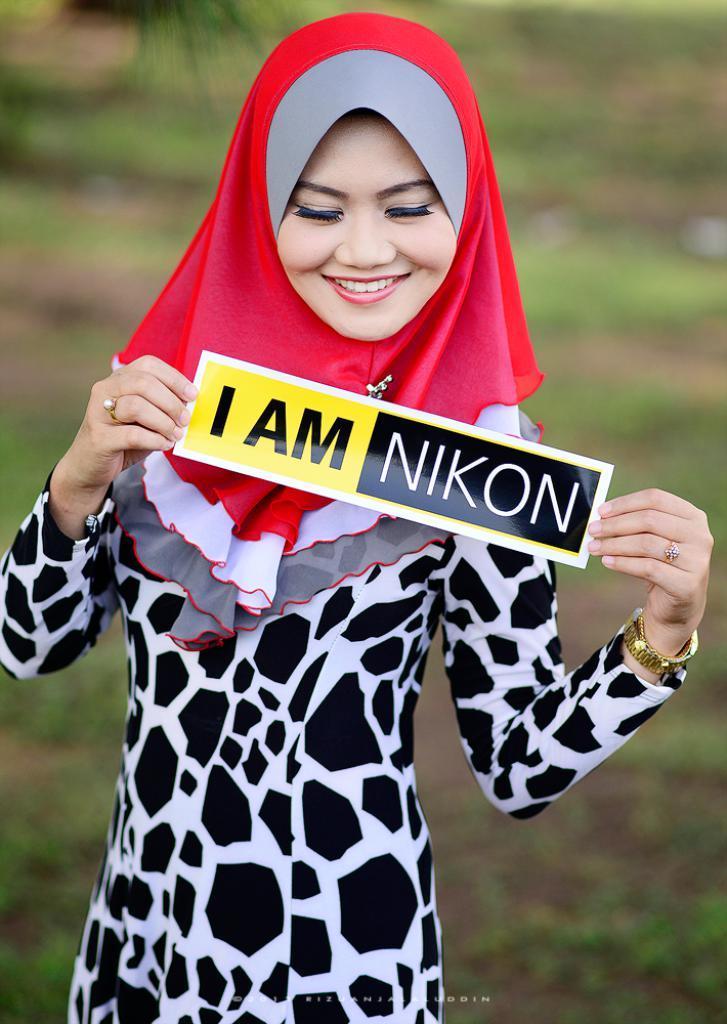Could you give a brief overview of what you see in this image? In this image I can see a woman is standing in the front and I can see she is holding a paper. I can also see something is written on the paper and I can see she is wearing a golden colour watch and black and white colour dress. I can also see smile on her face and I can see a red colour cloth on her head. In the background I can see an open grass ground and I can see this image is little bit blurry in the background. 